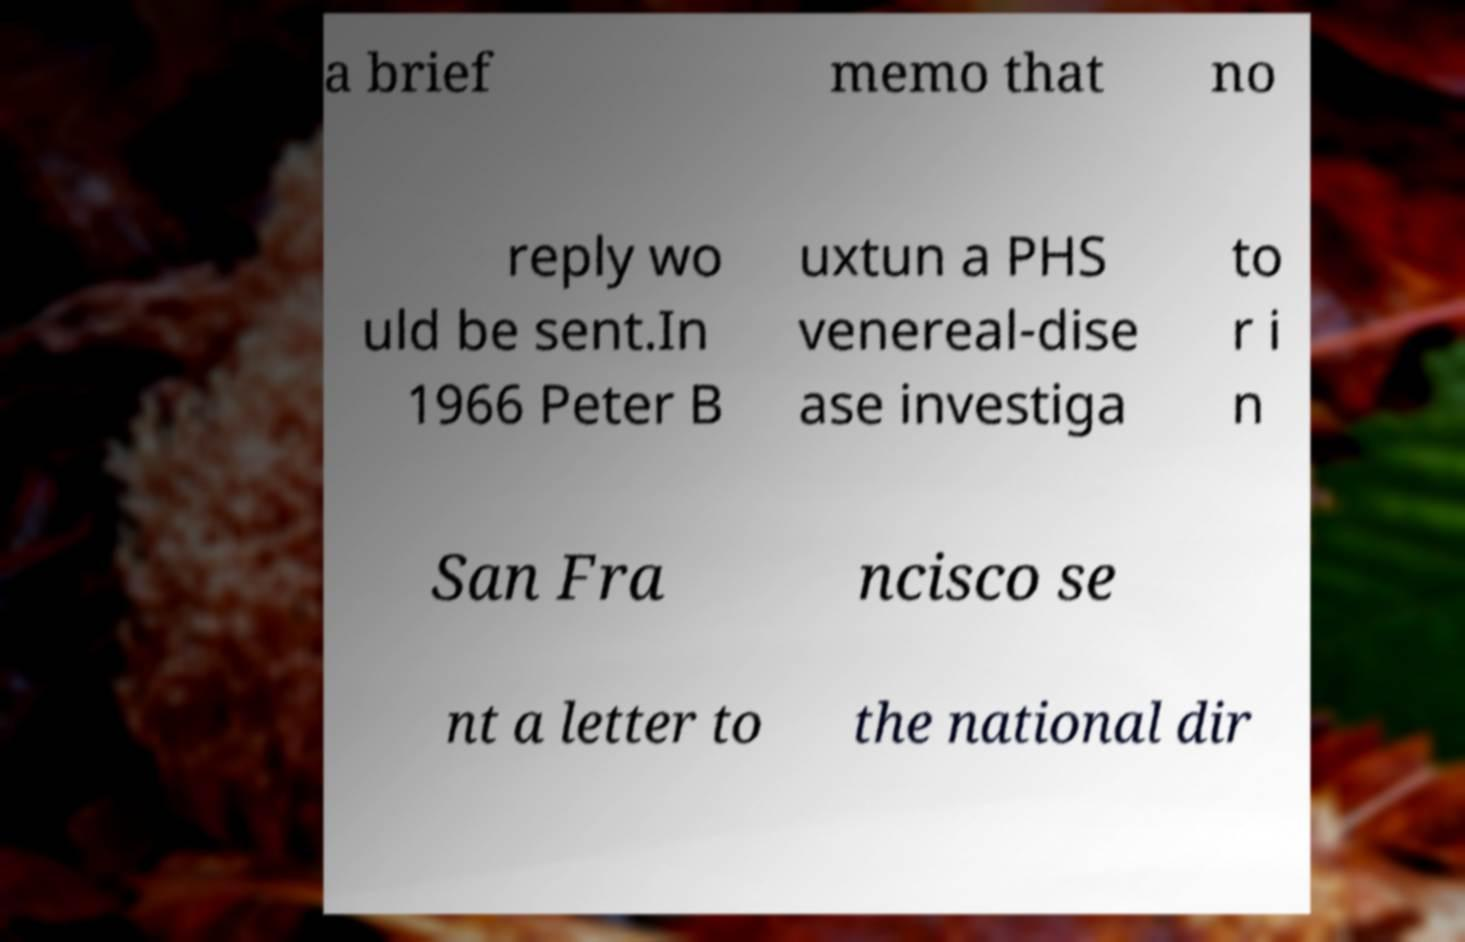Could you assist in decoding the text presented in this image and type it out clearly? a brief memo that no reply wo uld be sent.In 1966 Peter B uxtun a PHS venereal-dise ase investiga to r i n San Fra ncisco se nt a letter to the national dir 